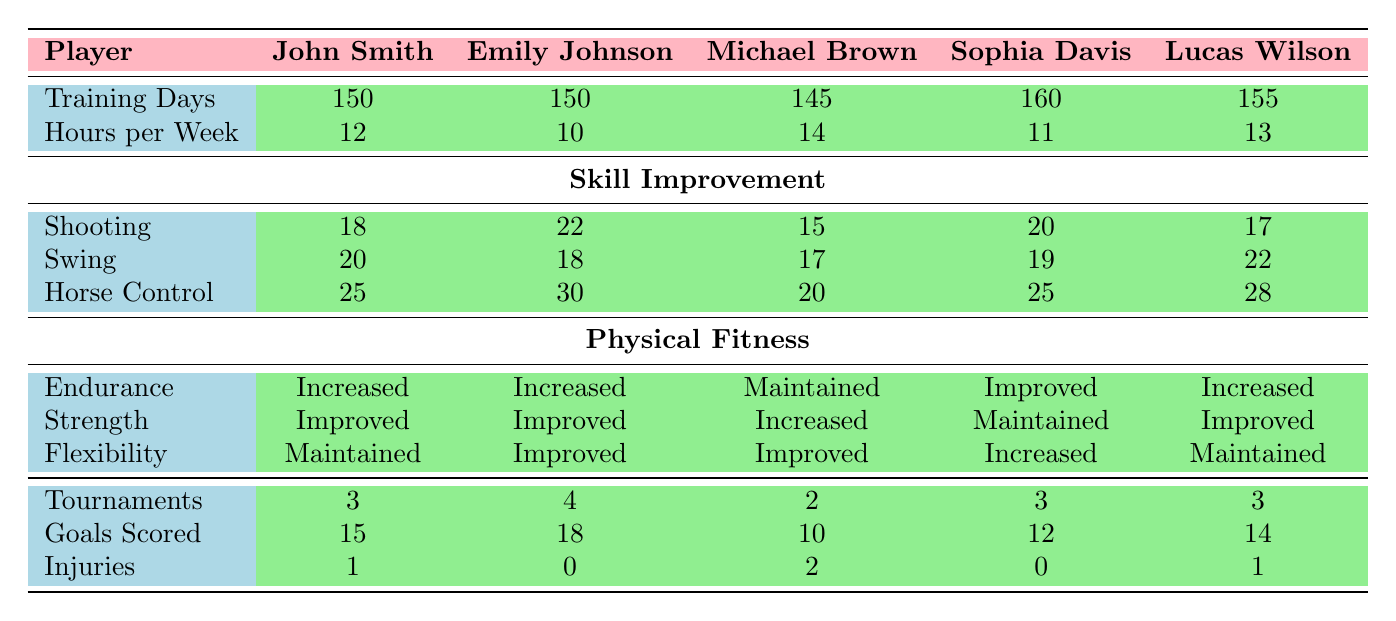What is the maximum number of tournaments participated in by a player? Looking at the table under the "Tournaments" section, Emily Johnson participated in the highest number of tournaments, which is 4.
Answer: 4 Which player had the highest improvement in shooting skill? Referring to the "Shooting" row in the "Skill Improvement" section, Emily Johnson showed the most significant improvement with a score of 22.
Answer: Emily Johnson What is the total number of injuries across all players? Adding the "Injuries" for each player gives: 1 + 0 + 2 + 0 + 1 = 4.
Answer: 4 Which player had the longest training days? In the "Training Days" section, Sophia Davis had the highest count with 160 training days.
Answer: Sophia Davis What is the average number of goals scored by the players? Summing the "Goals Scored" values: 15 + 18 + 10 + 12 + 14 = 69, then dividing by the total number of players (5): 69 / 5 = 13.8.
Answer: 13.8 Did any player maintain their physical fitness in all categories? By examining the "Physical Fitness" section, Michael Brown maintained his endurance, but he did not maintain all categories as strength increased and flexibility improved. No player maintained all categories.
Answer: No Which player had the lowest improvement in horse control? Referring to the "Horse Control" row, Michael Brown had the lowest improvement with a score of 20.
Answer: Michael Brown What is the difference in goals scored between the player with the highest and lowest scores? Emily Johnson had the highest goals scored at 18, and Michael Brown had the lowest with 10. Therefore, the difference is 18 - 10 = 8.
Answer: 8 Which player increased their endurance and also participated in exactly 3 tournaments? Both John Smith and Sophia Davis increased their endurance and participated in 3 tournaments.
Answer: John Smith and Sophia Davis What percentage of the players had injuries? There are 5 players, and 4 players had injuries (1, 0, 2, 0, 1). The percentage is (4/5) * 100 = 80%.
Answer: 80% 